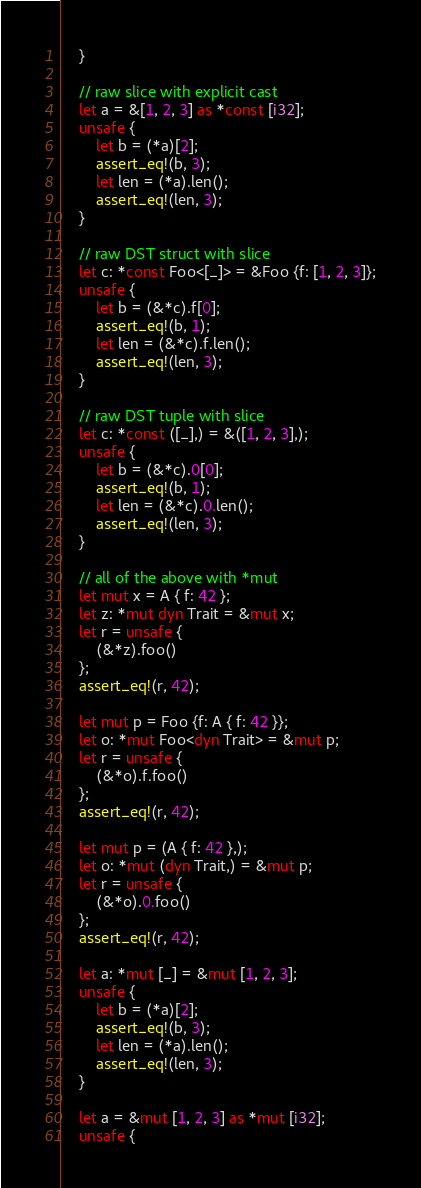Convert code to text. <code><loc_0><loc_0><loc_500><loc_500><_Rust_>    }

    // raw slice with explicit cast
    let a = &[1, 2, 3] as *const [i32];
    unsafe {
        let b = (*a)[2];
        assert_eq!(b, 3);
        let len = (*a).len();
        assert_eq!(len, 3);
    }

    // raw DST struct with slice
    let c: *const Foo<[_]> = &Foo {f: [1, 2, 3]};
    unsafe {
        let b = (&*c).f[0];
        assert_eq!(b, 1);
        let len = (&*c).f.len();
        assert_eq!(len, 3);
    }

    // raw DST tuple with slice
    let c: *const ([_],) = &([1, 2, 3],);
    unsafe {
        let b = (&*c).0[0];
        assert_eq!(b, 1);
        let len = (&*c).0.len();
        assert_eq!(len, 3);
    }

    // all of the above with *mut
    let mut x = A { f: 42 };
    let z: *mut dyn Trait = &mut x;
    let r = unsafe {
        (&*z).foo()
    };
    assert_eq!(r, 42);

    let mut p = Foo {f: A { f: 42 }};
    let o: *mut Foo<dyn Trait> = &mut p;
    let r = unsafe {
        (&*o).f.foo()
    };
    assert_eq!(r, 42);

    let mut p = (A { f: 42 },);
    let o: *mut (dyn Trait,) = &mut p;
    let r = unsafe {
        (&*o).0.foo()
    };
    assert_eq!(r, 42);

    let a: *mut [_] = &mut [1, 2, 3];
    unsafe {
        let b = (*a)[2];
        assert_eq!(b, 3);
        let len = (*a).len();
        assert_eq!(len, 3);
    }

    let a = &mut [1, 2, 3] as *mut [i32];
    unsafe {</code> 